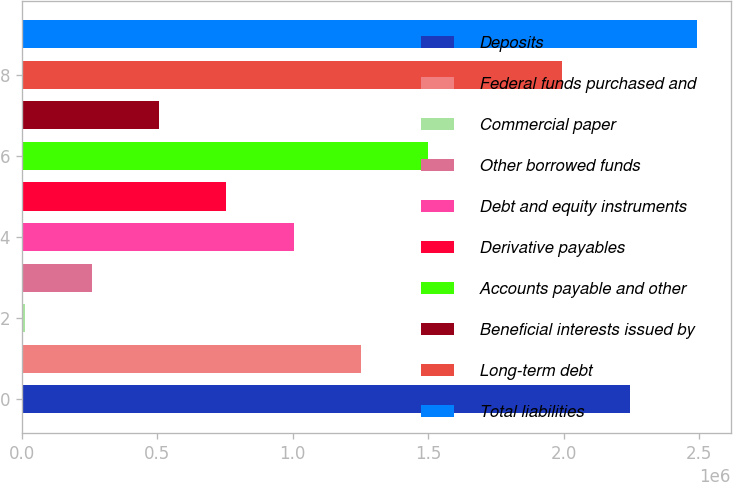Convert chart to OTSL. <chart><loc_0><loc_0><loc_500><loc_500><bar_chart><fcel>Deposits<fcel>Federal funds purchased and<fcel>Commercial paper<fcel>Other borrowed funds<fcel>Debt and equity instruments<fcel>Derivative payables<fcel>Accounts payable and other<fcel>Beneficial interests issued by<fcel>Long-term debt<fcel>Total liabilities<nl><fcel>2.24305e+06<fcel>1.25136e+06<fcel>11738<fcel>259661<fcel>1.00343e+06<fcel>755508<fcel>1.49928e+06<fcel>507585<fcel>1.99513e+06<fcel>2.49097e+06<nl></chart> 